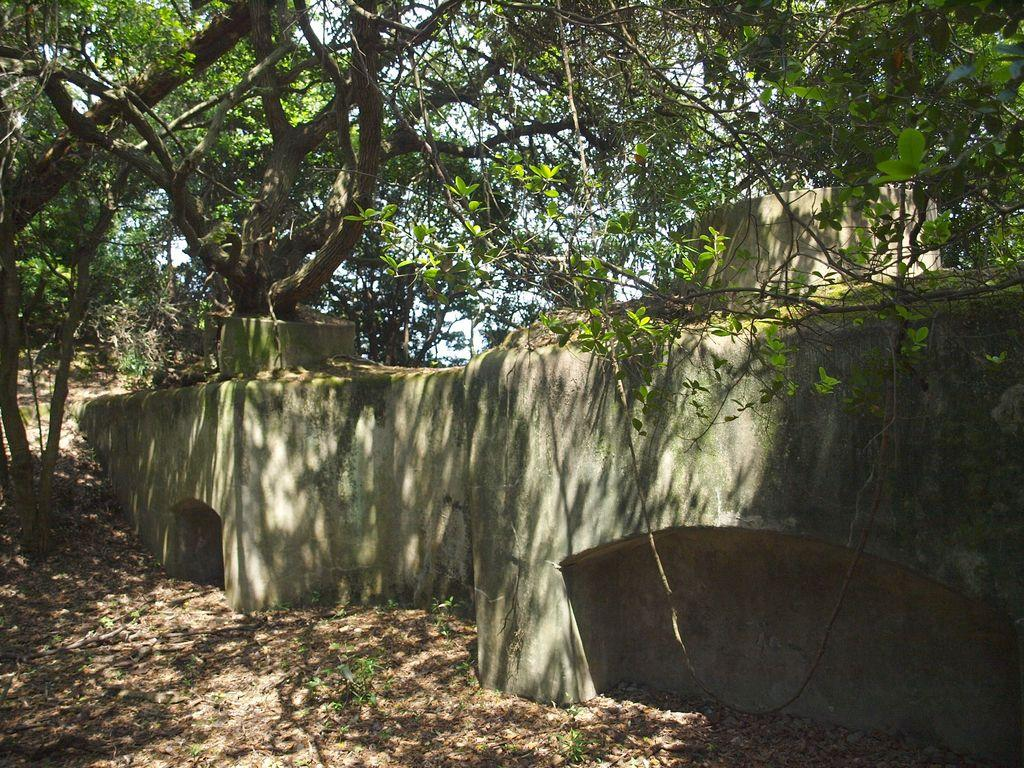What is present in the image that serves as a barrier or divider? There is a wall in the image. What can be seen on the ground in the image? There are dried leaves on the ground in the image. What type of vegetation is visible in the image? There are green color trees in the image. How many ladybugs can be seen on the bread in the image? There is no bread or ladybugs present in the image. What type of birds are perched on the branches of the trees in the image? There are no birds visible in the image; only trees and dried leaves on the ground are present. 